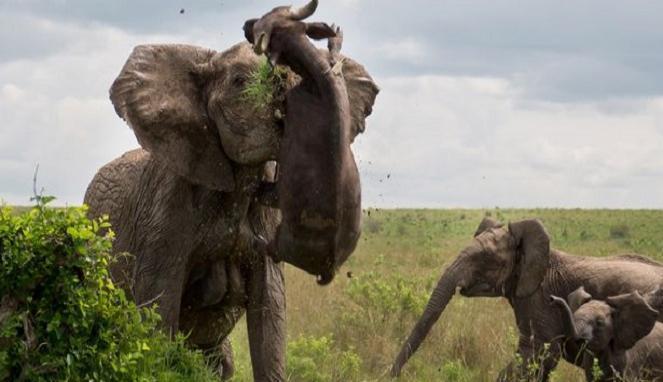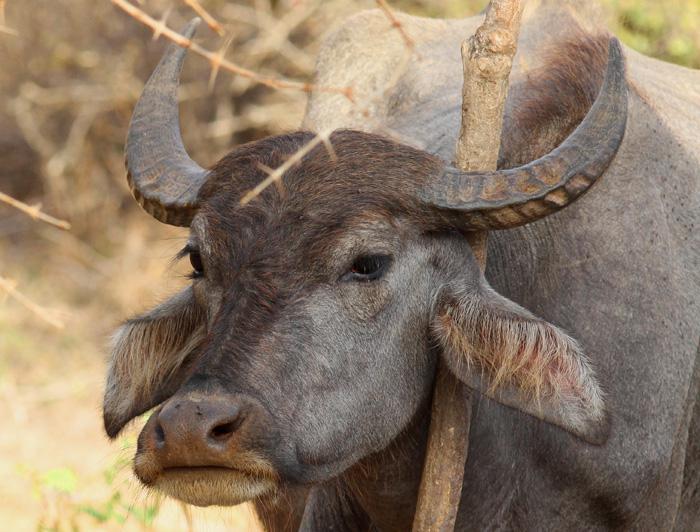The first image is the image on the left, the second image is the image on the right. Assess this claim about the two images: "In each image, there is at least one cow looking directly at the camera.". Correct or not? Answer yes or no. No. The first image is the image on the left, the second image is the image on the right. Considering the images on both sides, is "Each image includes a water buffalo with its face mostly forward." valid? Answer yes or no. No. 